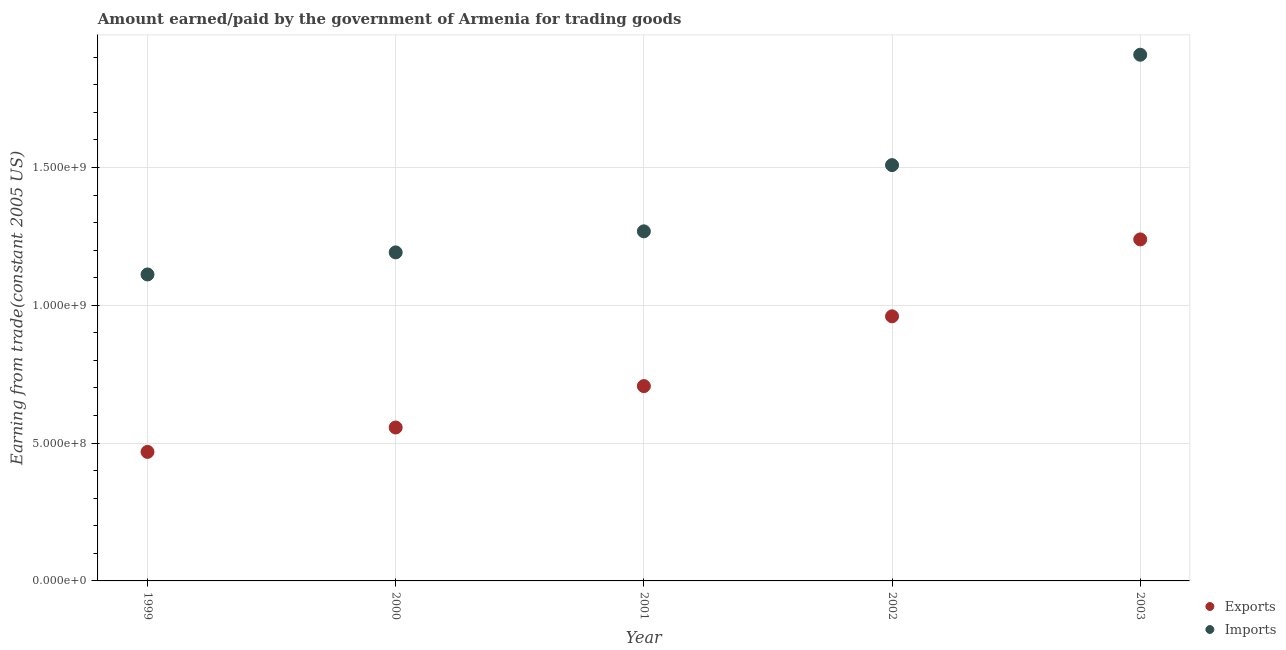How many different coloured dotlines are there?
Offer a very short reply. 2. What is the amount paid for imports in 2002?
Ensure brevity in your answer.  1.51e+09. Across all years, what is the maximum amount paid for imports?
Offer a terse response. 1.91e+09. Across all years, what is the minimum amount paid for imports?
Offer a very short reply. 1.11e+09. In which year was the amount paid for imports minimum?
Your answer should be very brief. 1999. What is the total amount earned from exports in the graph?
Keep it short and to the point. 3.93e+09. What is the difference between the amount earned from exports in 2000 and that in 2001?
Your response must be concise. -1.50e+08. What is the difference between the amount earned from exports in 2001 and the amount paid for imports in 2002?
Provide a short and direct response. -8.02e+08. What is the average amount paid for imports per year?
Ensure brevity in your answer.  1.40e+09. In the year 2000, what is the difference between the amount earned from exports and amount paid for imports?
Keep it short and to the point. -6.35e+08. In how many years, is the amount paid for imports greater than 600000000 US$?
Your answer should be very brief. 5. What is the ratio of the amount paid for imports in 1999 to that in 2000?
Your response must be concise. 0.93. Is the amount earned from exports in 1999 less than that in 2002?
Ensure brevity in your answer.  Yes. What is the difference between the highest and the second highest amount earned from exports?
Offer a very short reply. 2.79e+08. What is the difference between the highest and the lowest amount paid for imports?
Provide a short and direct response. 7.97e+08. Does the amount earned from exports monotonically increase over the years?
Offer a terse response. Yes. Is the amount earned from exports strictly greater than the amount paid for imports over the years?
Give a very brief answer. No. Is the amount paid for imports strictly less than the amount earned from exports over the years?
Provide a short and direct response. No. How many dotlines are there?
Provide a short and direct response. 2. What is the difference between two consecutive major ticks on the Y-axis?
Provide a short and direct response. 5.00e+08. Where does the legend appear in the graph?
Offer a very short reply. Bottom right. How many legend labels are there?
Offer a very short reply. 2. What is the title of the graph?
Offer a terse response. Amount earned/paid by the government of Armenia for trading goods. What is the label or title of the X-axis?
Your response must be concise. Year. What is the label or title of the Y-axis?
Provide a succinct answer. Earning from trade(constant 2005 US). What is the Earning from trade(constant 2005 US) of Exports in 1999?
Provide a short and direct response. 4.68e+08. What is the Earning from trade(constant 2005 US) of Imports in 1999?
Provide a succinct answer. 1.11e+09. What is the Earning from trade(constant 2005 US) in Exports in 2000?
Make the answer very short. 5.57e+08. What is the Earning from trade(constant 2005 US) in Imports in 2000?
Your response must be concise. 1.19e+09. What is the Earning from trade(constant 2005 US) in Exports in 2001?
Ensure brevity in your answer.  7.07e+08. What is the Earning from trade(constant 2005 US) in Imports in 2001?
Ensure brevity in your answer.  1.27e+09. What is the Earning from trade(constant 2005 US) of Exports in 2002?
Your answer should be compact. 9.60e+08. What is the Earning from trade(constant 2005 US) in Imports in 2002?
Your answer should be compact. 1.51e+09. What is the Earning from trade(constant 2005 US) of Exports in 2003?
Offer a very short reply. 1.24e+09. What is the Earning from trade(constant 2005 US) in Imports in 2003?
Your response must be concise. 1.91e+09. Across all years, what is the maximum Earning from trade(constant 2005 US) in Exports?
Make the answer very short. 1.24e+09. Across all years, what is the maximum Earning from trade(constant 2005 US) in Imports?
Provide a short and direct response. 1.91e+09. Across all years, what is the minimum Earning from trade(constant 2005 US) of Exports?
Offer a very short reply. 4.68e+08. Across all years, what is the minimum Earning from trade(constant 2005 US) of Imports?
Your answer should be compact. 1.11e+09. What is the total Earning from trade(constant 2005 US) of Exports in the graph?
Make the answer very short. 3.93e+09. What is the total Earning from trade(constant 2005 US) of Imports in the graph?
Offer a terse response. 6.99e+09. What is the difference between the Earning from trade(constant 2005 US) in Exports in 1999 and that in 2000?
Your response must be concise. -8.85e+07. What is the difference between the Earning from trade(constant 2005 US) of Imports in 1999 and that in 2000?
Offer a very short reply. -8.01e+07. What is the difference between the Earning from trade(constant 2005 US) in Exports in 1999 and that in 2001?
Your answer should be very brief. -2.39e+08. What is the difference between the Earning from trade(constant 2005 US) in Imports in 1999 and that in 2001?
Your answer should be very brief. -1.56e+08. What is the difference between the Earning from trade(constant 2005 US) of Exports in 1999 and that in 2002?
Offer a very short reply. -4.92e+08. What is the difference between the Earning from trade(constant 2005 US) of Imports in 1999 and that in 2002?
Offer a very short reply. -3.97e+08. What is the difference between the Earning from trade(constant 2005 US) of Exports in 1999 and that in 2003?
Ensure brevity in your answer.  -7.71e+08. What is the difference between the Earning from trade(constant 2005 US) in Imports in 1999 and that in 2003?
Keep it short and to the point. -7.97e+08. What is the difference between the Earning from trade(constant 2005 US) of Exports in 2000 and that in 2001?
Make the answer very short. -1.50e+08. What is the difference between the Earning from trade(constant 2005 US) of Imports in 2000 and that in 2001?
Your response must be concise. -7.64e+07. What is the difference between the Earning from trade(constant 2005 US) of Exports in 2000 and that in 2002?
Provide a short and direct response. -4.03e+08. What is the difference between the Earning from trade(constant 2005 US) of Imports in 2000 and that in 2002?
Ensure brevity in your answer.  -3.17e+08. What is the difference between the Earning from trade(constant 2005 US) in Exports in 2000 and that in 2003?
Provide a short and direct response. -6.82e+08. What is the difference between the Earning from trade(constant 2005 US) in Imports in 2000 and that in 2003?
Provide a short and direct response. -7.17e+08. What is the difference between the Earning from trade(constant 2005 US) in Exports in 2001 and that in 2002?
Offer a very short reply. -2.53e+08. What is the difference between the Earning from trade(constant 2005 US) of Imports in 2001 and that in 2002?
Your response must be concise. -2.40e+08. What is the difference between the Earning from trade(constant 2005 US) in Exports in 2001 and that in 2003?
Make the answer very short. -5.32e+08. What is the difference between the Earning from trade(constant 2005 US) in Imports in 2001 and that in 2003?
Make the answer very short. -6.41e+08. What is the difference between the Earning from trade(constant 2005 US) in Exports in 2002 and that in 2003?
Your answer should be compact. -2.79e+08. What is the difference between the Earning from trade(constant 2005 US) of Imports in 2002 and that in 2003?
Offer a very short reply. -4.00e+08. What is the difference between the Earning from trade(constant 2005 US) in Exports in 1999 and the Earning from trade(constant 2005 US) in Imports in 2000?
Give a very brief answer. -7.24e+08. What is the difference between the Earning from trade(constant 2005 US) in Exports in 1999 and the Earning from trade(constant 2005 US) in Imports in 2001?
Your answer should be very brief. -8.00e+08. What is the difference between the Earning from trade(constant 2005 US) of Exports in 1999 and the Earning from trade(constant 2005 US) of Imports in 2002?
Offer a very short reply. -1.04e+09. What is the difference between the Earning from trade(constant 2005 US) in Exports in 1999 and the Earning from trade(constant 2005 US) in Imports in 2003?
Make the answer very short. -1.44e+09. What is the difference between the Earning from trade(constant 2005 US) of Exports in 2000 and the Earning from trade(constant 2005 US) of Imports in 2001?
Your answer should be very brief. -7.12e+08. What is the difference between the Earning from trade(constant 2005 US) in Exports in 2000 and the Earning from trade(constant 2005 US) in Imports in 2002?
Provide a short and direct response. -9.52e+08. What is the difference between the Earning from trade(constant 2005 US) in Exports in 2000 and the Earning from trade(constant 2005 US) in Imports in 2003?
Offer a very short reply. -1.35e+09. What is the difference between the Earning from trade(constant 2005 US) of Exports in 2001 and the Earning from trade(constant 2005 US) of Imports in 2002?
Your response must be concise. -8.02e+08. What is the difference between the Earning from trade(constant 2005 US) in Exports in 2001 and the Earning from trade(constant 2005 US) in Imports in 2003?
Your answer should be compact. -1.20e+09. What is the difference between the Earning from trade(constant 2005 US) in Exports in 2002 and the Earning from trade(constant 2005 US) in Imports in 2003?
Offer a terse response. -9.49e+08. What is the average Earning from trade(constant 2005 US) in Exports per year?
Your answer should be compact. 7.86e+08. What is the average Earning from trade(constant 2005 US) in Imports per year?
Keep it short and to the point. 1.40e+09. In the year 1999, what is the difference between the Earning from trade(constant 2005 US) in Exports and Earning from trade(constant 2005 US) in Imports?
Provide a succinct answer. -6.44e+08. In the year 2000, what is the difference between the Earning from trade(constant 2005 US) in Exports and Earning from trade(constant 2005 US) in Imports?
Your response must be concise. -6.35e+08. In the year 2001, what is the difference between the Earning from trade(constant 2005 US) in Exports and Earning from trade(constant 2005 US) in Imports?
Ensure brevity in your answer.  -5.62e+08. In the year 2002, what is the difference between the Earning from trade(constant 2005 US) of Exports and Earning from trade(constant 2005 US) of Imports?
Offer a terse response. -5.49e+08. In the year 2003, what is the difference between the Earning from trade(constant 2005 US) of Exports and Earning from trade(constant 2005 US) of Imports?
Offer a very short reply. -6.70e+08. What is the ratio of the Earning from trade(constant 2005 US) of Exports in 1999 to that in 2000?
Provide a succinct answer. 0.84. What is the ratio of the Earning from trade(constant 2005 US) of Imports in 1999 to that in 2000?
Your answer should be compact. 0.93. What is the ratio of the Earning from trade(constant 2005 US) in Exports in 1999 to that in 2001?
Make the answer very short. 0.66. What is the ratio of the Earning from trade(constant 2005 US) of Imports in 1999 to that in 2001?
Your response must be concise. 0.88. What is the ratio of the Earning from trade(constant 2005 US) in Exports in 1999 to that in 2002?
Provide a succinct answer. 0.49. What is the ratio of the Earning from trade(constant 2005 US) of Imports in 1999 to that in 2002?
Give a very brief answer. 0.74. What is the ratio of the Earning from trade(constant 2005 US) of Exports in 1999 to that in 2003?
Keep it short and to the point. 0.38. What is the ratio of the Earning from trade(constant 2005 US) in Imports in 1999 to that in 2003?
Your answer should be compact. 0.58. What is the ratio of the Earning from trade(constant 2005 US) in Exports in 2000 to that in 2001?
Ensure brevity in your answer.  0.79. What is the ratio of the Earning from trade(constant 2005 US) of Imports in 2000 to that in 2001?
Your response must be concise. 0.94. What is the ratio of the Earning from trade(constant 2005 US) in Exports in 2000 to that in 2002?
Keep it short and to the point. 0.58. What is the ratio of the Earning from trade(constant 2005 US) of Imports in 2000 to that in 2002?
Provide a succinct answer. 0.79. What is the ratio of the Earning from trade(constant 2005 US) of Exports in 2000 to that in 2003?
Give a very brief answer. 0.45. What is the ratio of the Earning from trade(constant 2005 US) in Imports in 2000 to that in 2003?
Make the answer very short. 0.62. What is the ratio of the Earning from trade(constant 2005 US) of Exports in 2001 to that in 2002?
Ensure brevity in your answer.  0.74. What is the ratio of the Earning from trade(constant 2005 US) of Imports in 2001 to that in 2002?
Make the answer very short. 0.84. What is the ratio of the Earning from trade(constant 2005 US) in Exports in 2001 to that in 2003?
Offer a terse response. 0.57. What is the ratio of the Earning from trade(constant 2005 US) of Imports in 2001 to that in 2003?
Offer a terse response. 0.66. What is the ratio of the Earning from trade(constant 2005 US) of Exports in 2002 to that in 2003?
Offer a terse response. 0.77. What is the ratio of the Earning from trade(constant 2005 US) of Imports in 2002 to that in 2003?
Provide a short and direct response. 0.79. What is the difference between the highest and the second highest Earning from trade(constant 2005 US) of Exports?
Make the answer very short. 2.79e+08. What is the difference between the highest and the second highest Earning from trade(constant 2005 US) of Imports?
Provide a succinct answer. 4.00e+08. What is the difference between the highest and the lowest Earning from trade(constant 2005 US) in Exports?
Make the answer very short. 7.71e+08. What is the difference between the highest and the lowest Earning from trade(constant 2005 US) in Imports?
Your answer should be very brief. 7.97e+08. 